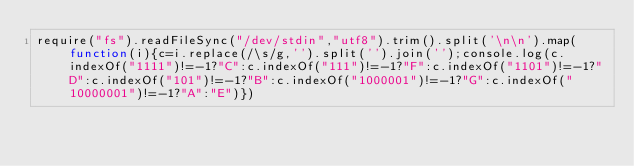Convert code to text. <code><loc_0><loc_0><loc_500><loc_500><_JavaScript_>require("fs").readFileSync("/dev/stdin","utf8").trim().split('\n\n').map(function(i){c=i.replace(/\s/g,'').split('').join('');console.log(c.indexOf("1111")!=-1?"C":c.indexOf("111")!=-1?"F":c.indexOf("1101")!=-1?"D":c.indexOf("101")!=-1?"B":c.indexOf("1000001")!=-1?"G":c.indexOf("10000001")!=-1?"A":"E")})</code> 